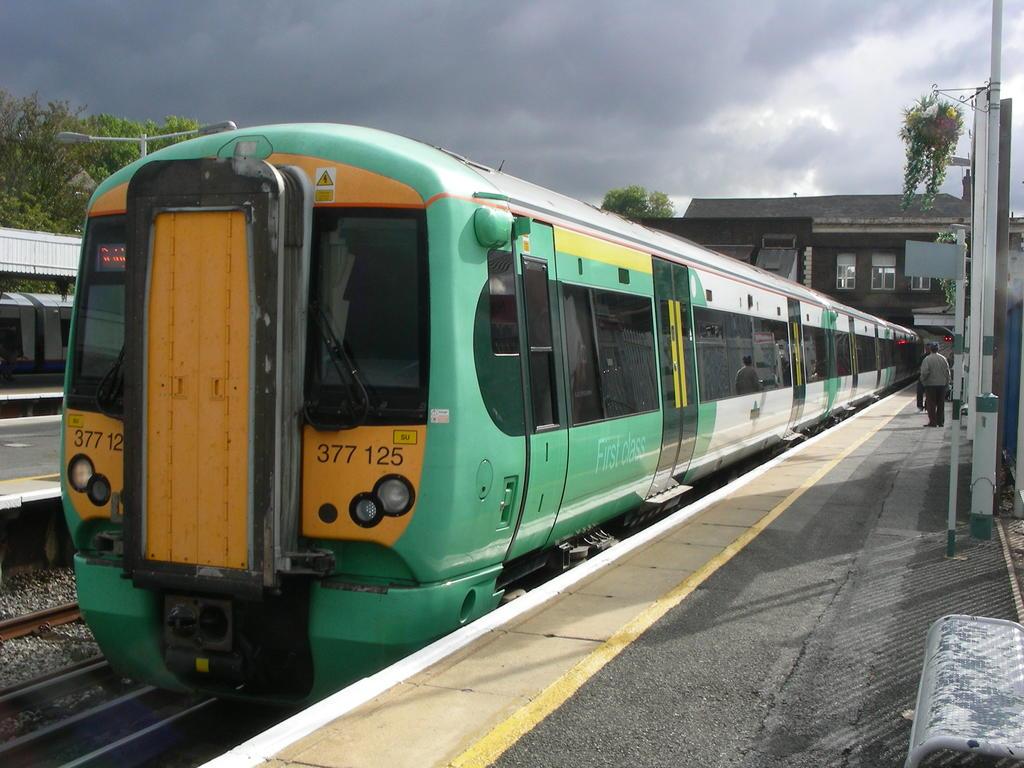What number is this train?
Provide a succinct answer. 377 125. What are the words written in white letters on the side of the train?
Make the answer very short. First class. 